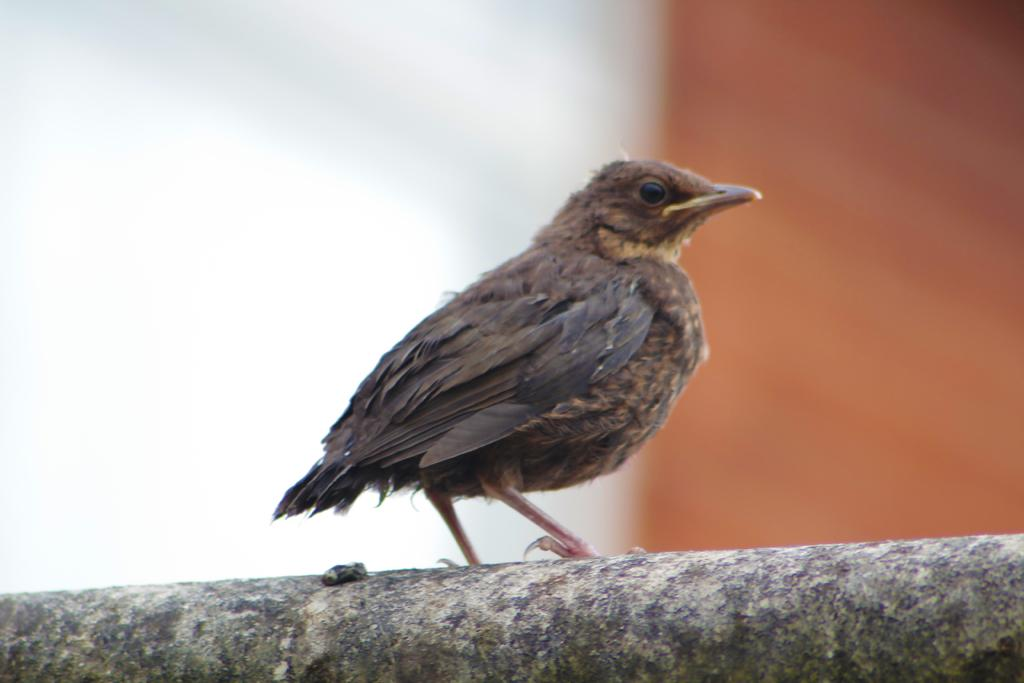What type of animal can be seen in the image? There is a bird in the image. Where is the bird located? The bird is on a stone-like structure. Can you describe the background of the image? The background of the image is blurred. What type of list can be seen hanging on the gate in the image? There is no gate or list present in the image; it features a bird on a stone-like structure with a blurred background. 